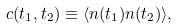Convert formula to latex. <formula><loc_0><loc_0><loc_500><loc_500>c ( t _ { 1 } , t _ { 2 } ) \equiv \langle n ( t _ { 1 } ) n ( t _ { 2 } ) \rangle ,</formula> 